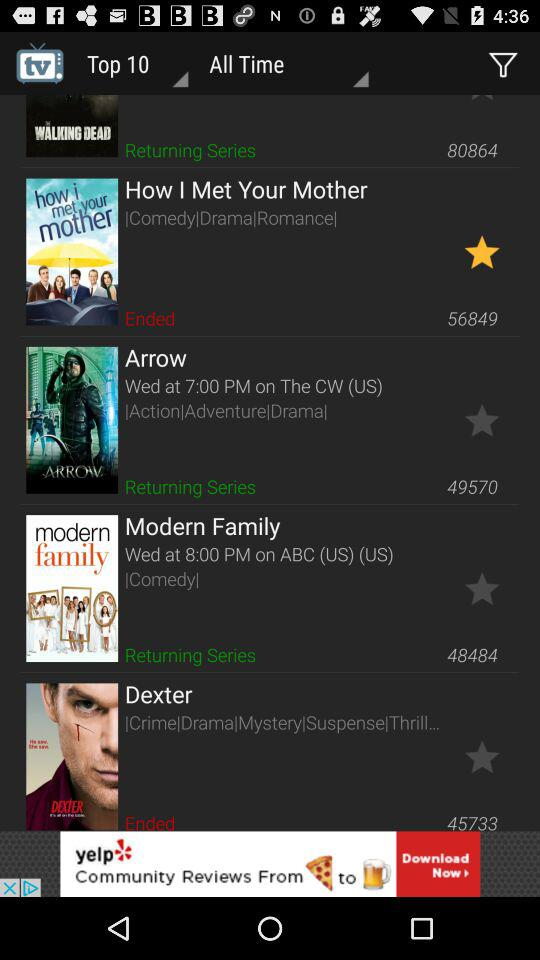What is the airtime of "Modern Family" series? The airtime is 8:00 p.m. 